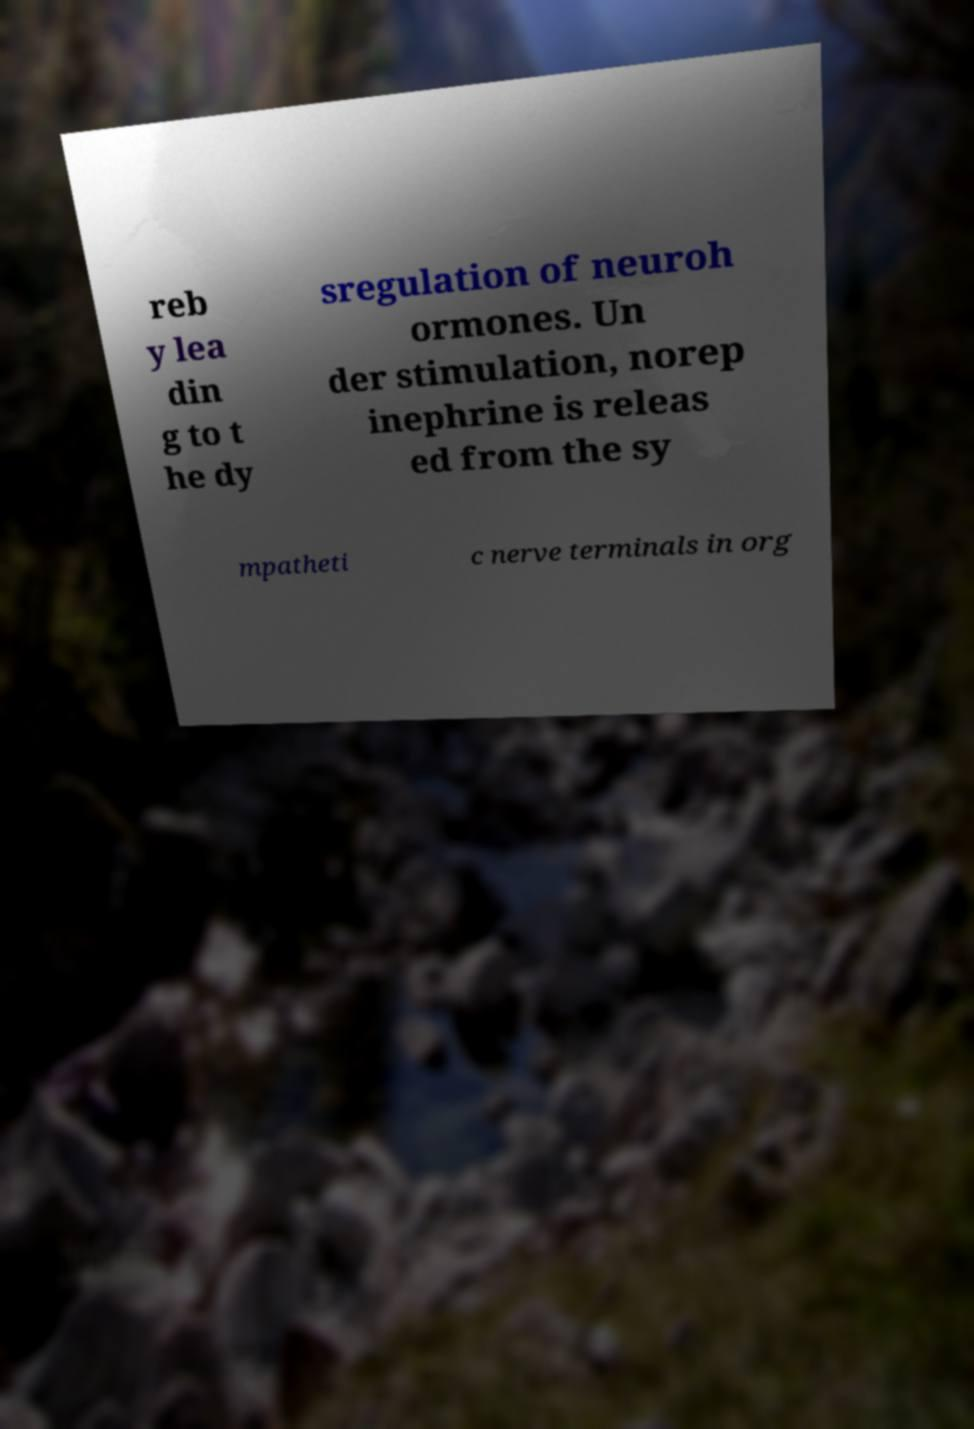Please identify and transcribe the text found in this image. reb y lea din g to t he dy sregulation of neuroh ormones. Un der stimulation, norep inephrine is releas ed from the sy mpatheti c nerve terminals in org 